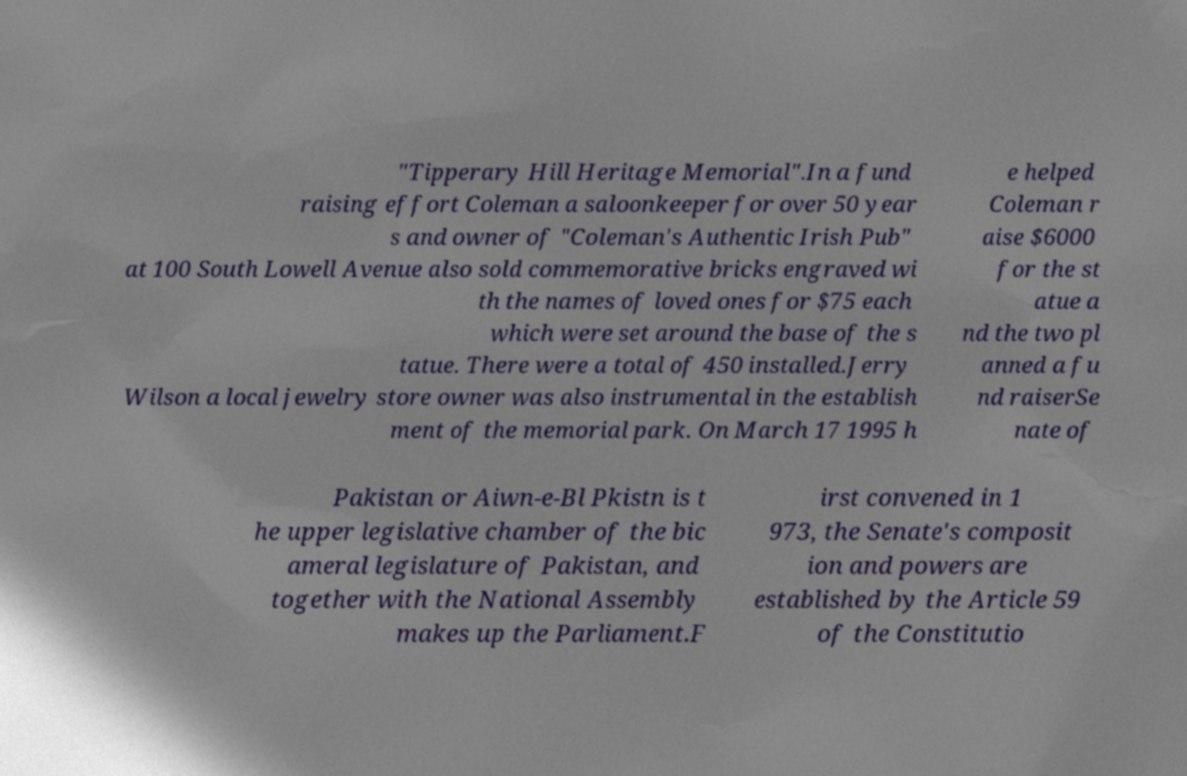I need the written content from this picture converted into text. Can you do that? "Tipperary Hill Heritage Memorial".In a fund raising effort Coleman a saloonkeeper for over 50 year s and owner of "Coleman's Authentic Irish Pub" at 100 South Lowell Avenue also sold commemorative bricks engraved wi th the names of loved ones for $75 each which were set around the base of the s tatue. There were a total of 450 installed.Jerry Wilson a local jewelry store owner was also instrumental in the establish ment of the memorial park. On March 17 1995 h e helped Coleman r aise $6000 for the st atue a nd the two pl anned a fu nd raiserSe nate of Pakistan or Aiwn-e-Bl Pkistn is t he upper legislative chamber of the bic ameral legislature of Pakistan, and together with the National Assembly makes up the Parliament.F irst convened in 1 973, the Senate's composit ion and powers are established by the Article 59 of the Constitutio 